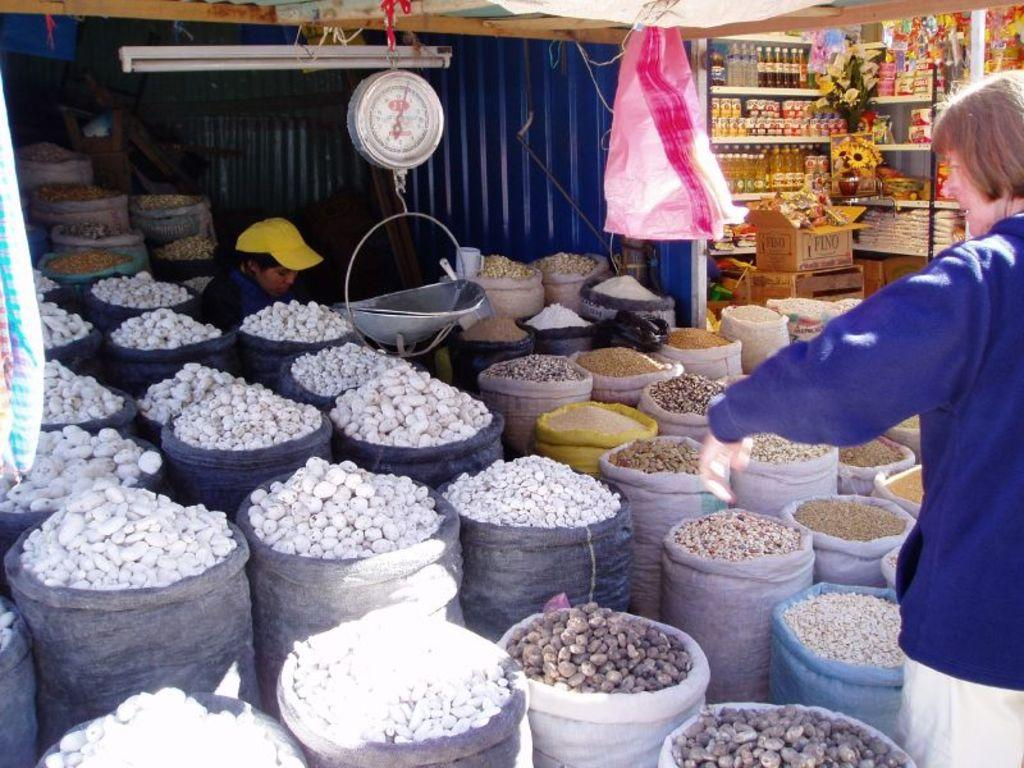What type of items can be seen in bags in the image? There are food items in bags in the image. What other items can be seen in the image besides the bags? There are bottles, packets on shelves, cardboard boxes, and people visible in the image. What might be used to measure the weight of items in the image? There is a weighing-machine in the image. Can you see any fairies or kittens in the image? No, there are no fairies or kittens present in the image. What type of thrill can be experienced by the people in the image? The image does not depict any specific thrilling activity or experience for the people present. 